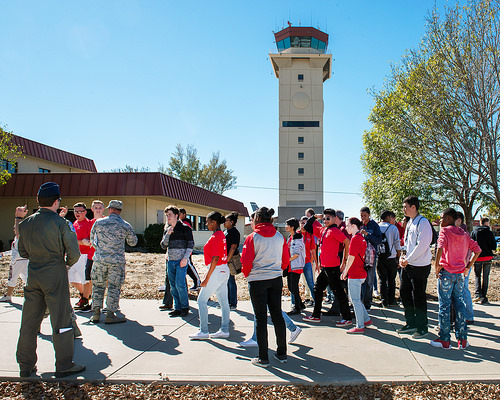<image>
Is there a man behind the man? Yes. From this viewpoint, the man is positioned behind the man, with the man partially or fully occluding the man. Is the soldier in the building? No. The soldier is not contained within the building. These objects have a different spatial relationship. 